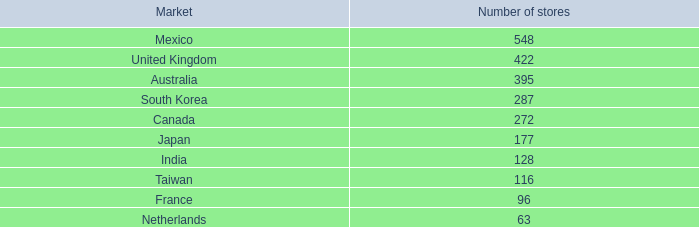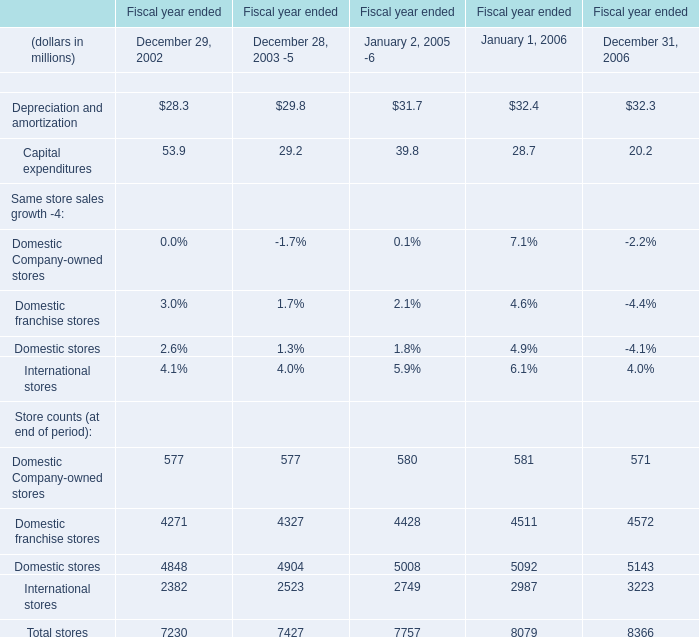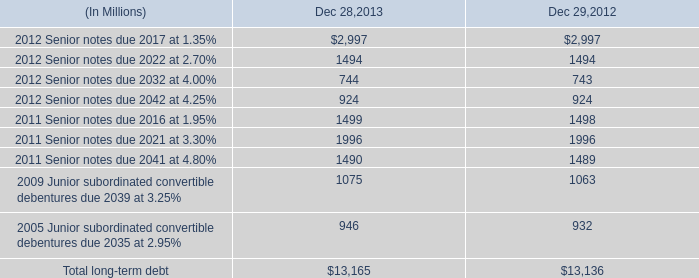What was the sum of store counts (at the end of period) without those store counts (at the end of period) smaller than 3000 ( in 2002 )? (in million) 
Computations: (4271 + 4848)
Answer: 9119.0. 